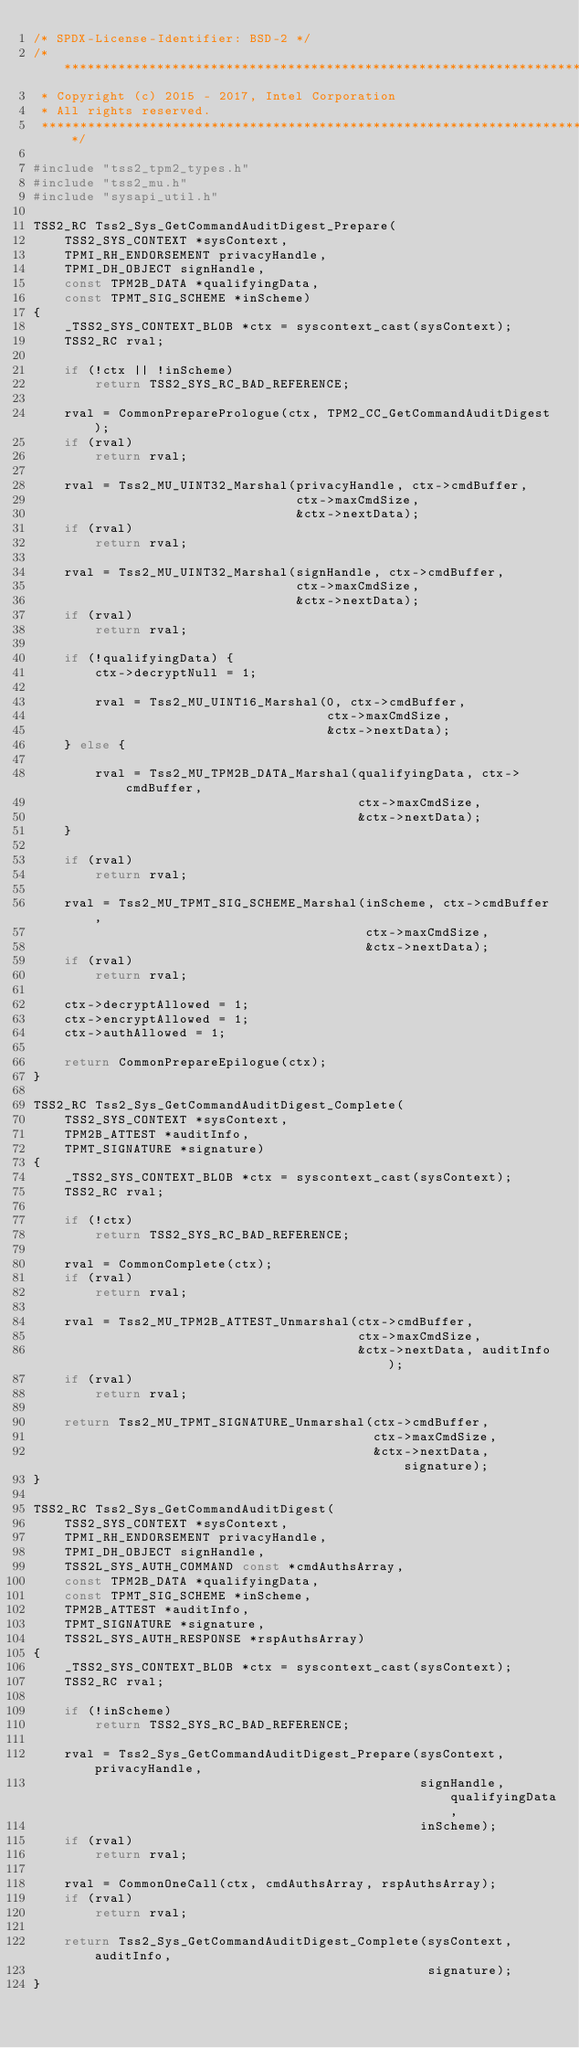<code> <loc_0><loc_0><loc_500><loc_500><_C_>/* SPDX-License-Identifier: BSD-2 */
/***********************************************************************;
 * Copyright (c) 2015 - 2017, Intel Corporation
 * All rights reserved.
 ***********************************************************************/

#include "tss2_tpm2_types.h"
#include "tss2_mu.h"
#include "sysapi_util.h"

TSS2_RC Tss2_Sys_GetCommandAuditDigest_Prepare(
    TSS2_SYS_CONTEXT *sysContext,
    TPMI_RH_ENDORSEMENT privacyHandle,
    TPMI_DH_OBJECT signHandle,
    const TPM2B_DATA *qualifyingData,
    const TPMT_SIG_SCHEME *inScheme)
{
    _TSS2_SYS_CONTEXT_BLOB *ctx = syscontext_cast(sysContext);
    TSS2_RC rval;

    if (!ctx || !inScheme)
        return TSS2_SYS_RC_BAD_REFERENCE;

    rval = CommonPreparePrologue(ctx, TPM2_CC_GetCommandAuditDigest);
    if (rval)
        return rval;

    rval = Tss2_MU_UINT32_Marshal(privacyHandle, ctx->cmdBuffer,
                                  ctx->maxCmdSize,
                                  &ctx->nextData);
    if (rval)
        return rval;

    rval = Tss2_MU_UINT32_Marshal(signHandle, ctx->cmdBuffer,
                                  ctx->maxCmdSize,
                                  &ctx->nextData);
    if (rval)
        return rval;

    if (!qualifyingData) {
        ctx->decryptNull = 1;

        rval = Tss2_MU_UINT16_Marshal(0, ctx->cmdBuffer,
                                      ctx->maxCmdSize,
                                      &ctx->nextData);
    } else {

        rval = Tss2_MU_TPM2B_DATA_Marshal(qualifyingData, ctx->cmdBuffer,
                                          ctx->maxCmdSize,
                                          &ctx->nextData);
    }

    if (rval)
        return rval;

    rval = Tss2_MU_TPMT_SIG_SCHEME_Marshal(inScheme, ctx->cmdBuffer,
                                           ctx->maxCmdSize,
                                           &ctx->nextData);
    if (rval)
        return rval;

    ctx->decryptAllowed = 1;
    ctx->encryptAllowed = 1;
    ctx->authAllowed = 1;

    return CommonPrepareEpilogue(ctx);
}

TSS2_RC Tss2_Sys_GetCommandAuditDigest_Complete(
    TSS2_SYS_CONTEXT *sysContext,
    TPM2B_ATTEST *auditInfo,
    TPMT_SIGNATURE *signature)
{
    _TSS2_SYS_CONTEXT_BLOB *ctx = syscontext_cast(sysContext);
    TSS2_RC rval;

    if (!ctx)
        return TSS2_SYS_RC_BAD_REFERENCE;

    rval = CommonComplete(ctx);
    if (rval)
        return rval;

    rval = Tss2_MU_TPM2B_ATTEST_Unmarshal(ctx->cmdBuffer,
                                          ctx->maxCmdSize,
                                          &ctx->nextData, auditInfo);
    if (rval)
        return rval;

    return Tss2_MU_TPMT_SIGNATURE_Unmarshal(ctx->cmdBuffer,
                                            ctx->maxCmdSize,
                                            &ctx->nextData, signature);
}

TSS2_RC Tss2_Sys_GetCommandAuditDigest(
    TSS2_SYS_CONTEXT *sysContext,
    TPMI_RH_ENDORSEMENT privacyHandle,
    TPMI_DH_OBJECT signHandle,
    TSS2L_SYS_AUTH_COMMAND const *cmdAuthsArray,
    const TPM2B_DATA *qualifyingData,
    const TPMT_SIG_SCHEME *inScheme,
    TPM2B_ATTEST *auditInfo,
    TPMT_SIGNATURE *signature,
    TSS2L_SYS_AUTH_RESPONSE *rspAuthsArray)
{
    _TSS2_SYS_CONTEXT_BLOB *ctx = syscontext_cast(sysContext);
    TSS2_RC rval;

    if (!inScheme)
        return TSS2_SYS_RC_BAD_REFERENCE;

    rval = Tss2_Sys_GetCommandAuditDigest_Prepare(sysContext, privacyHandle,
                                                  signHandle, qualifyingData,
                                                  inScheme);
    if (rval)
        return rval;

    rval = CommonOneCall(ctx, cmdAuthsArray, rspAuthsArray);
    if (rval)
        return rval;

    return Tss2_Sys_GetCommandAuditDigest_Complete(sysContext, auditInfo,
                                                   signature);
}
</code> 